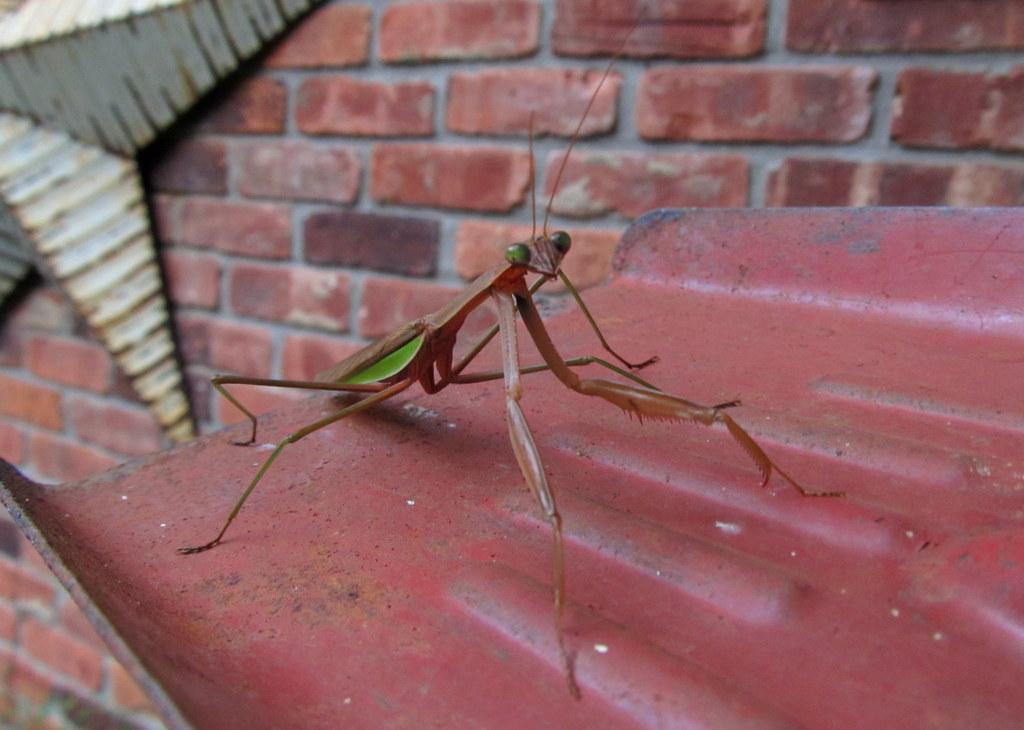In one or two sentences, can you explain what this image depicts? This is an insect, which is named as mantis, which is on an iron plate. I can see a star, which is attached to the wall. This is a wall, which is built with the bricks. 